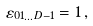Convert formula to latex. <formula><loc_0><loc_0><loc_500><loc_500>\varepsilon _ { 0 1 \dots D - 1 } = 1 \, ,</formula> 